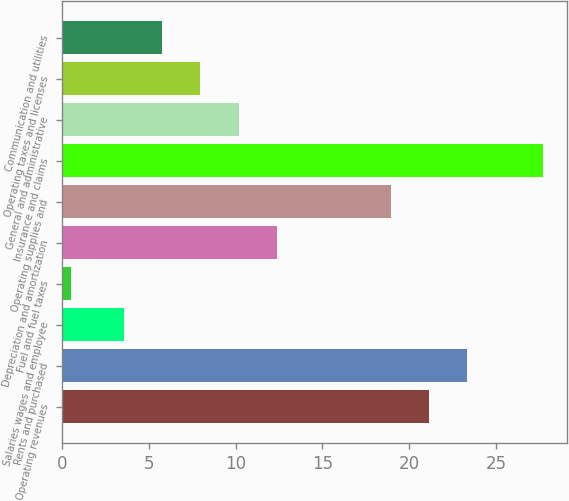<chart> <loc_0><loc_0><loc_500><loc_500><bar_chart><fcel>Operating revenues<fcel>Rents and purchased<fcel>Salaries wages and employee<fcel>Fuel and fuel taxes<fcel>Depreciation and amortization<fcel>Operating supplies and<fcel>Insurance and claims<fcel>General and administrative<fcel>Operating taxes and licenses<fcel>Communication and utilities<nl><fcel>21.12<fcel>23.31<fcel>3.6<fcel>0.5<fcel>12.36<fcel>18.93<fcel>27.69<fcel>10.17<fcel>7.98<fcel>5.79<nl></chart> 